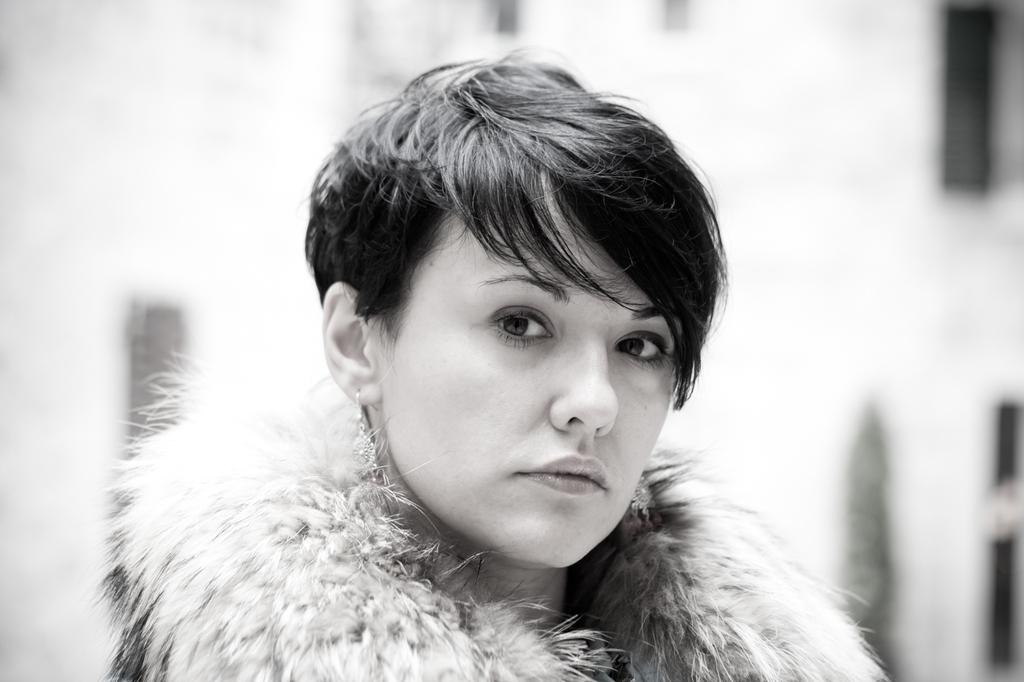What is the color scheme of the image? The image is black and white. Who is in the picture? There is a woman in the picture. What is the woman doing in the image? The woman is looking at the camera. What is the color of the area behind the woman? The area behind the woman is white in color. How is the background of the image depicted? The background is blurred. What letters can be seen on the woman's brain in the image? There are no letters visible on the woman's brain in the image, as the image is black and white and does not show any details of the woman's brain. 